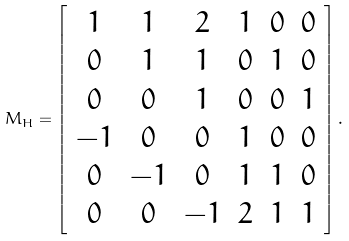Convert formula to latex. <formula><loc_0><loc_0><loc_500><loc_500>M _ { H } = \left [ \begin{array} { c c c c c c } 1 & 1 & 2 & 1 & 0 & 0 \\ 0 & 1 & 1 & 0 & 1 & 0 \\ 0 & 0 & 1 & 0 & 0 & 1 \\ - 1 & 0 & 0 & 1 & 0 & 0 \\ 0 & - 1 & 0 & 1 & 1 & 0 \\ 0 & 0 & - 1 & 2 & 1 & 1 \\ \end{array} \right ] .</formula> 